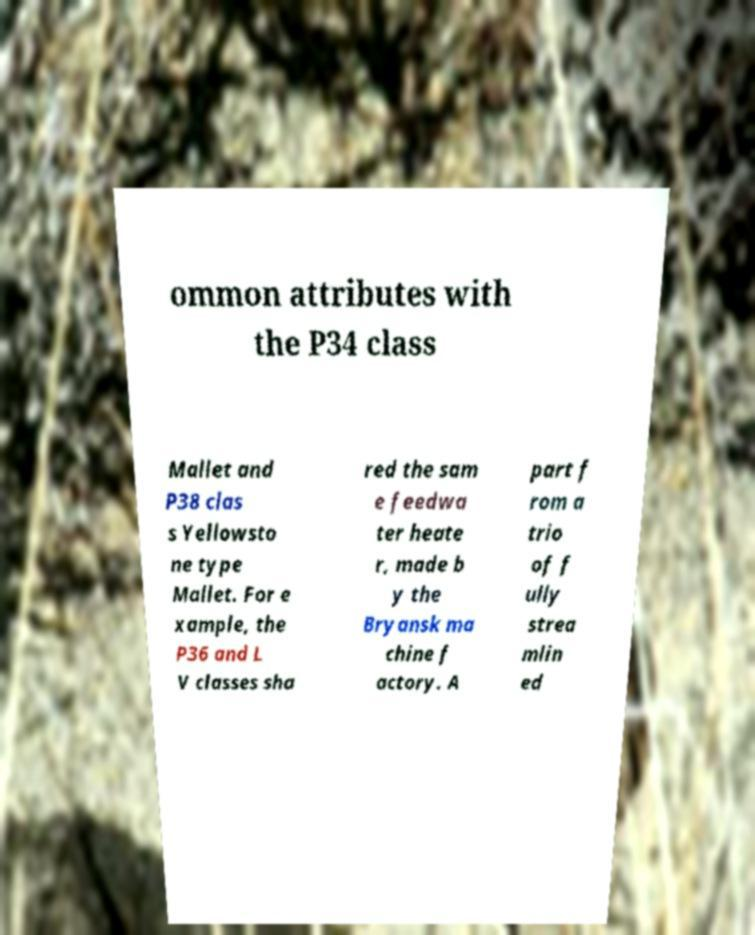There's text embedded in this image that I need extracted. Can you transcribe it verbatim? ommon attributes with the P34 class Mallet and P38 clas s Yellowsto ne type Mallet. For e xample, the P36 and L V classes sha red the sam e feedwa ter heate r, made b y the Bryansk ma chine f actory. A part f rom a trio of f ully strea mlin ed 